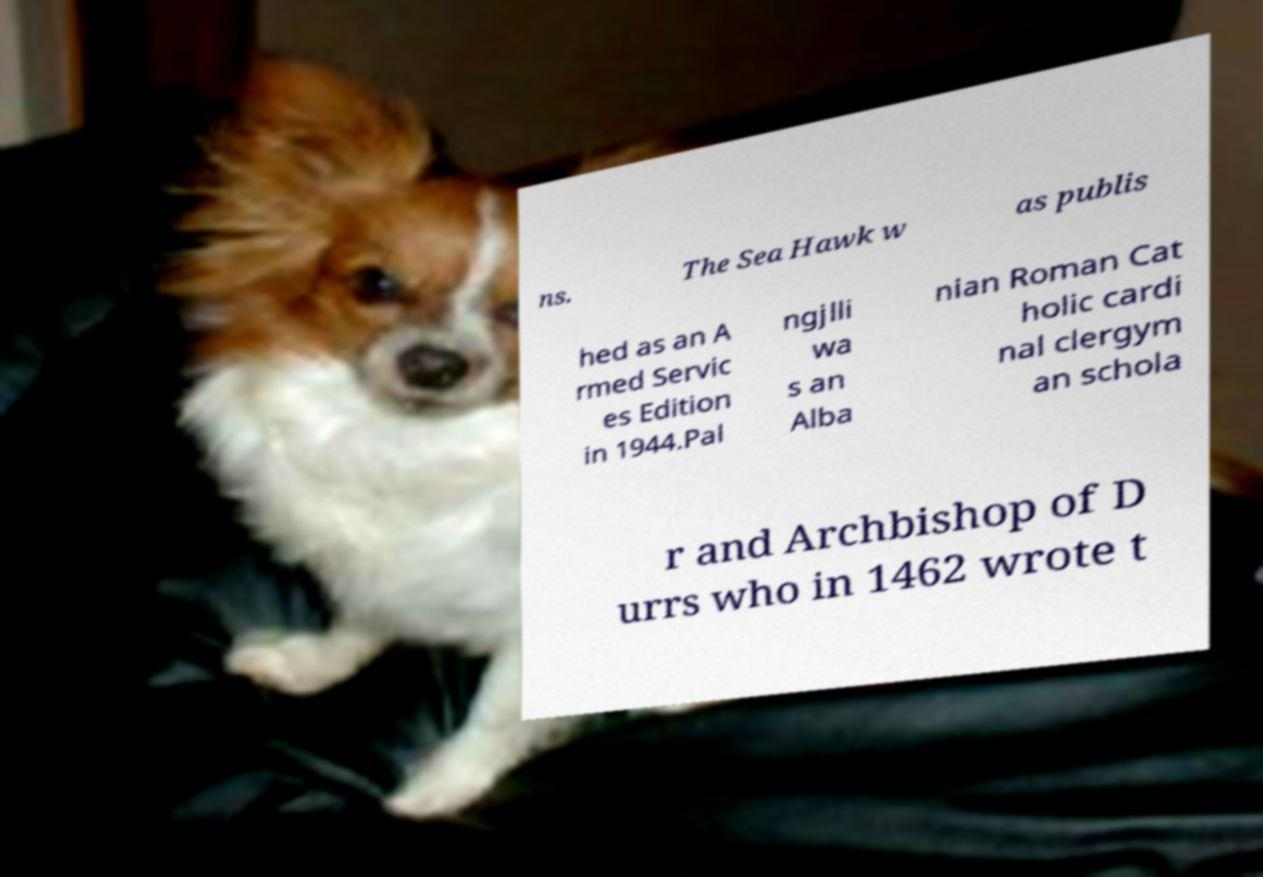Could you assist in decoding the text presented in this image and type it out clearly? ns. The Sea Hawk w as publis hed as an A rmed Servic es Edition in 1944.Pal ngjlli wa s an Alba nian Roman Cat holic cardi nal clergym an schola r and Archbishop of D urrs who in 1462 wrote t 